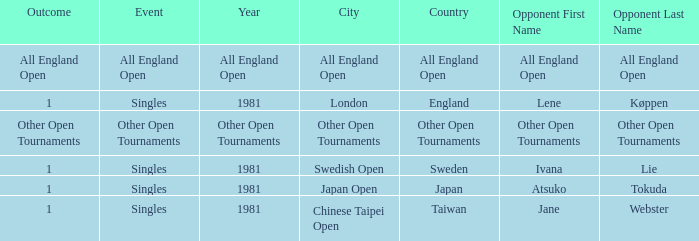What Event has an Outcome of other open tournaments? Other Open Tournaments. 